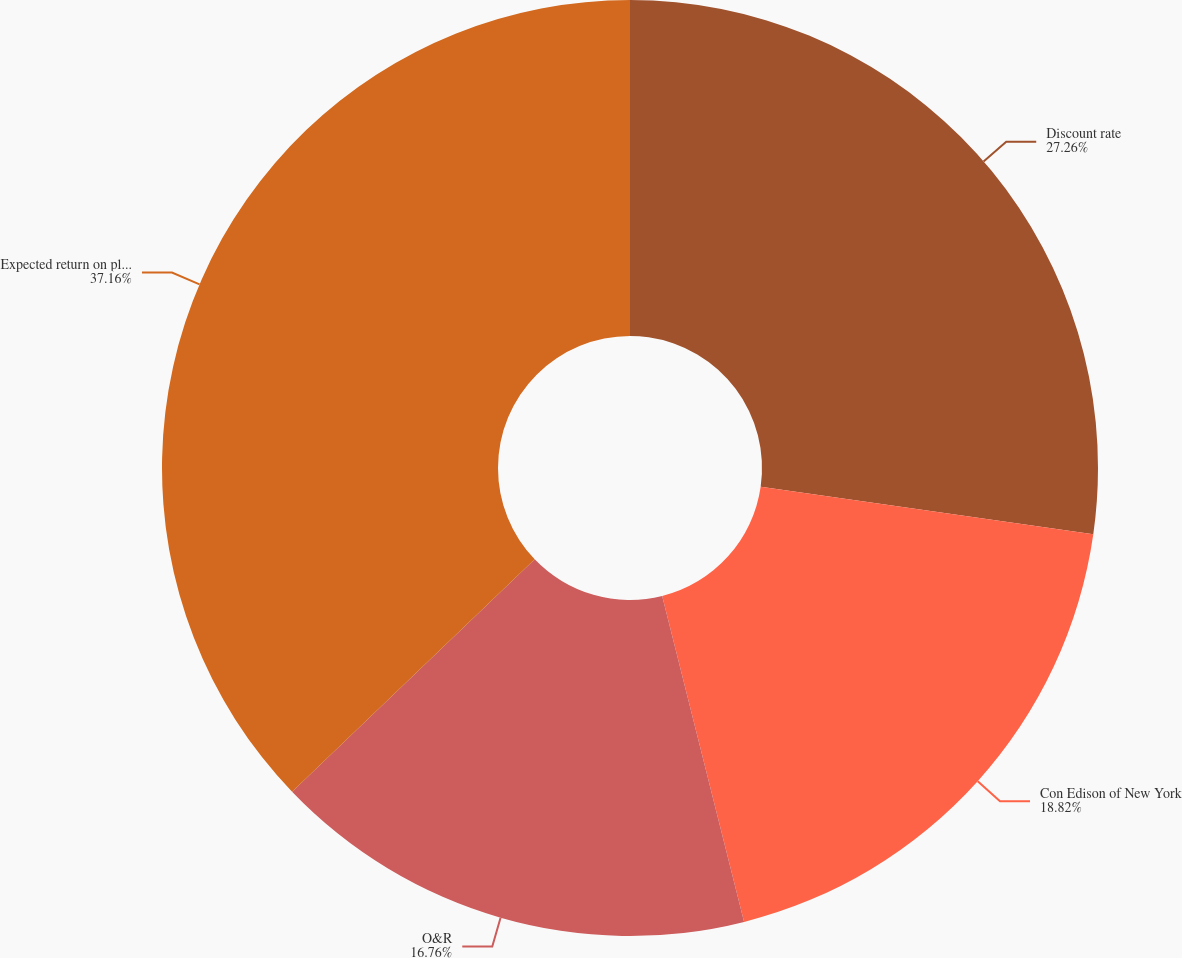Convert chart to OTSL. <chart><loc_0><loc_0><loc_500><loc_500><pie_chart><fcel>Discount rate<fcel>Con Edison of New York<fcel>O&R<fcel>Expected return on plan assets<nl><fcel>27.26%<fcel>18.82%<fcel>16.76%<fcel>37.16%<nl></chart> 